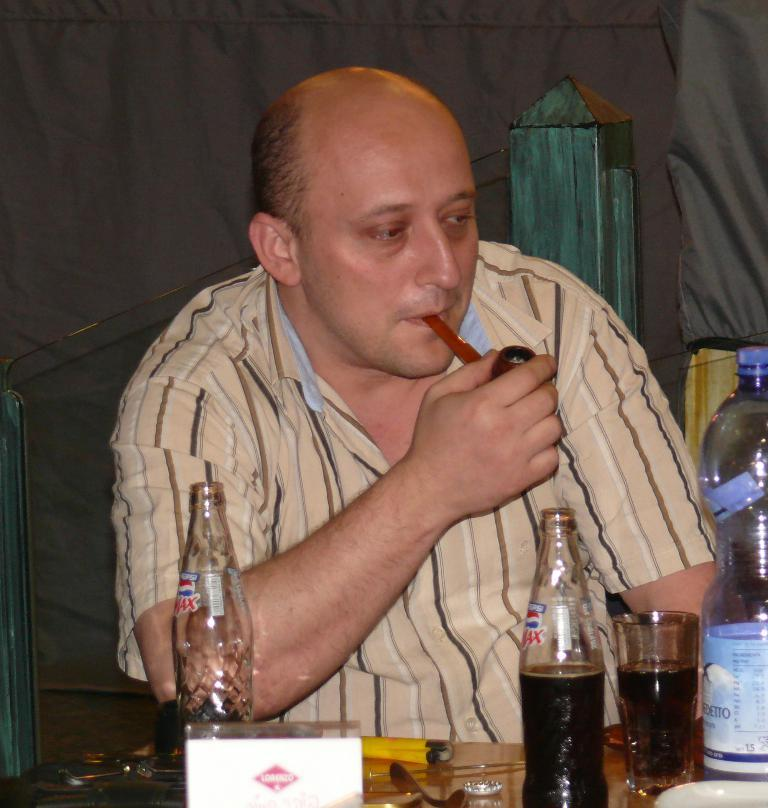What is the man in the image doing? The man is sitting on a chair in the image. What is in front of the man? There is a table in front of the man. What items can be seen on the table? There are bottles and a glass on the table. What is the man holding in the image? The man is holding a cigar. What type of flower is on the man's plate in the image? There is no flower or plate present in the image. What kind of oatmeal is the man eating in the image? There is no oatmeal visible in the image; the man is holding a cigar. 